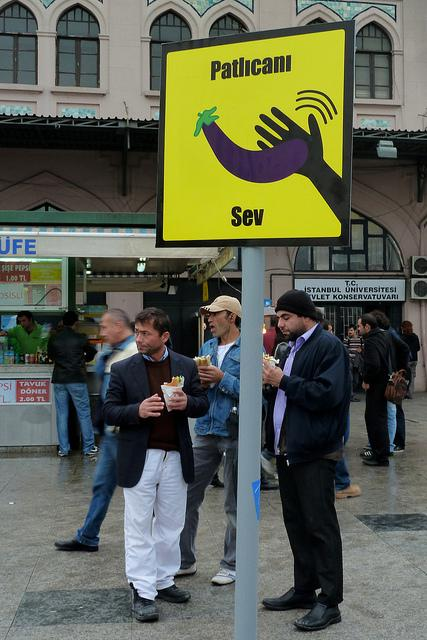What great empire once ruled this land? ottoman 